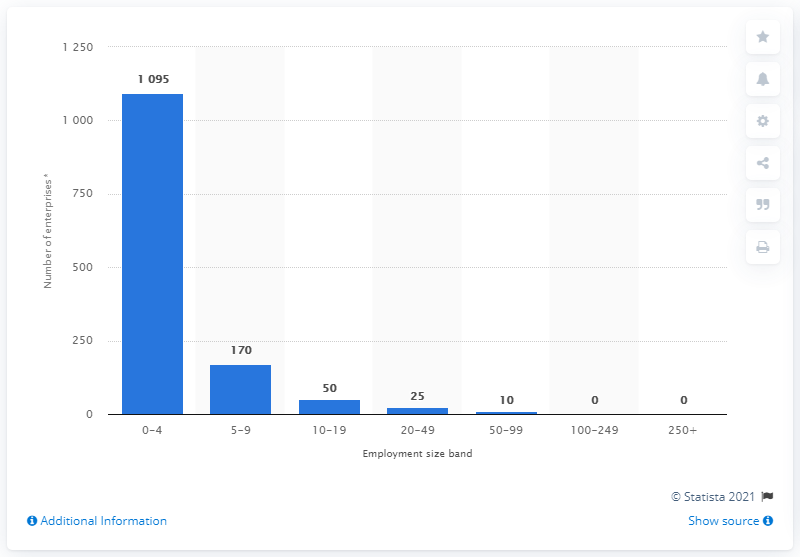Outline some significant characteristics in this image. As of March 2020, it is estimated that there were approximately 25 enterprises in the United States with between 20 and 49 employees. 